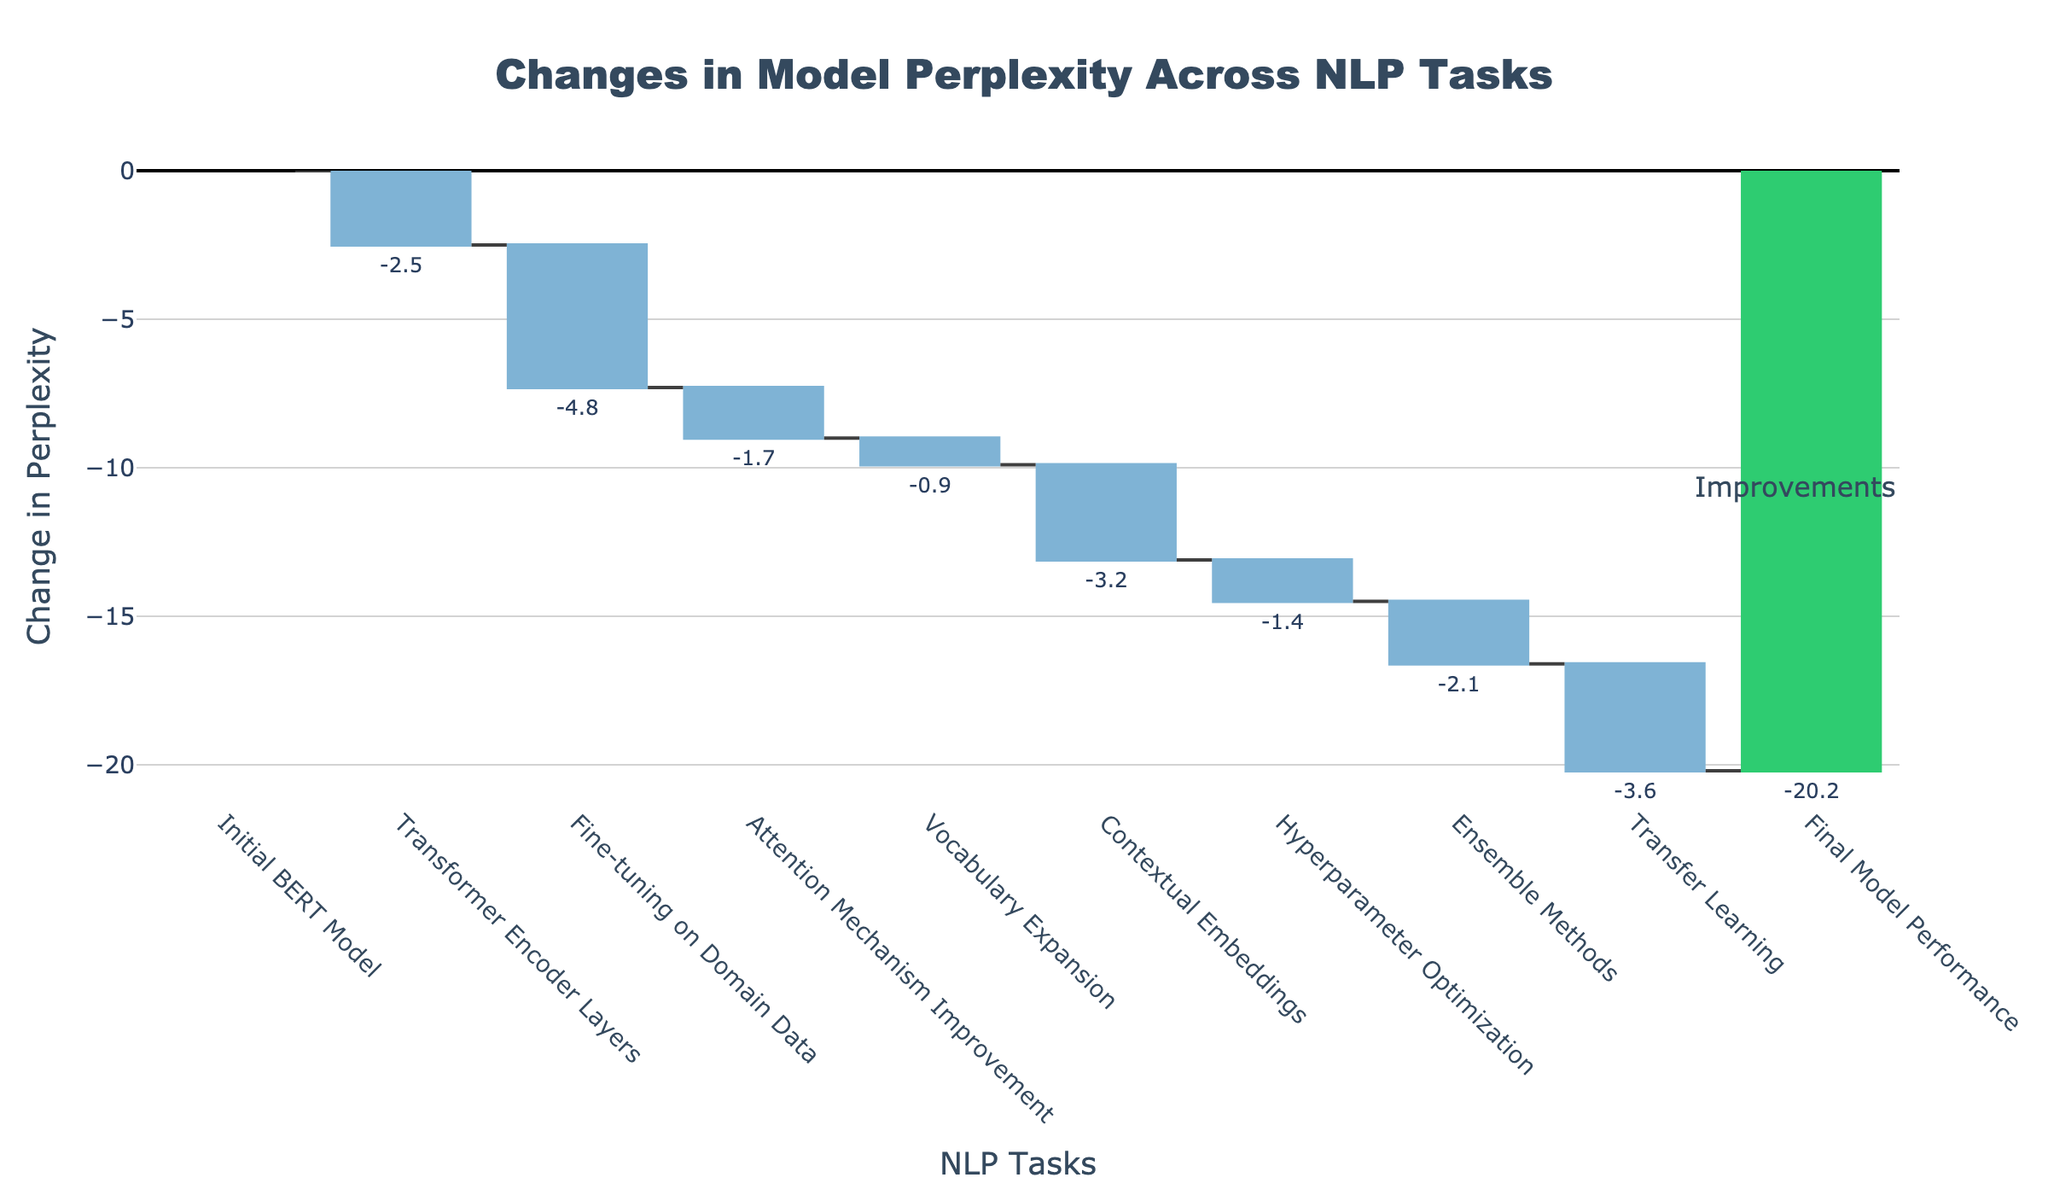What is the title of the chart? The title is usually displayed prominently at the top of the chart. In this figure, it reads "Changes in Model Perplexity Across NLP Tasks".
Answer: Changes in Model Perplexity Across NLP Tasks What is the change in perplexity for the 'Attention Mechanism Improvement' task? Look at the bar labeled 'Attention Mechanism Improvement' and read the text label or the height of this bar in relation to the y-axis.
Answer: -1.7 How many incremental changes are shown before reaching the final model performance? Count each individual task representation in the chart leading up to the final model performance.
Answer: 8 What is the cumulative change in perplexity after ‘Fine-tuning on Domain Data’? Find the cumulative value listed for 'Fine-tuning on Domain Data', which should be the point where previous changes are summed.
Answer: -7.3 Which task contributed the most in decreasing model perplexity? Identify the longest bar that extends downward, representing the maximum reduction in perplexity.
Answer: Fine-tuning on Domain Data What is the overall change in perplexity from the initial BERT Model to the Final Model Performance? Subtract the final value from the initial value. The initial value is 0 and the final value is -20.2, giving a change of -20.2.
Answer: -20.2 Which task showed the smallest improvement in perplexity? Look for the bar with the smallest value downward.
Answer: Vocabulary Expansion What combined effect do 'Transformer Encoder Layers' and 'Fine-tuning on Domain Data' have on perplexity? Add the changes in perplexity from both tasks: -2.5 (Transformer Encoder Layers) + -4.8 (Fine-tuning on Domain Data).
Answer: -7.3 Which two tasks have nearly equal improvements in perplexity? Compare the changes in perplexity across tasks visually; 'Attention Mechanism Improvement' (-1.7) and 'Hyperparameter Optimization' (-1.4) are close.
Answer: Attention Mechanism Improvement and Hyperparameter Optimization How does the final model performance compare to the combined contributions of 'Ensemble Methods' and 'Transfer Learning'? Add the changes in perplexity from both tasks (Ensemble Methods: -2.1 + Transfer Learning: -3.6) and compare them to the final value. The combined contributions is -5.7 while the final model performance is -20.2.
Answer: Final model performance is greater 